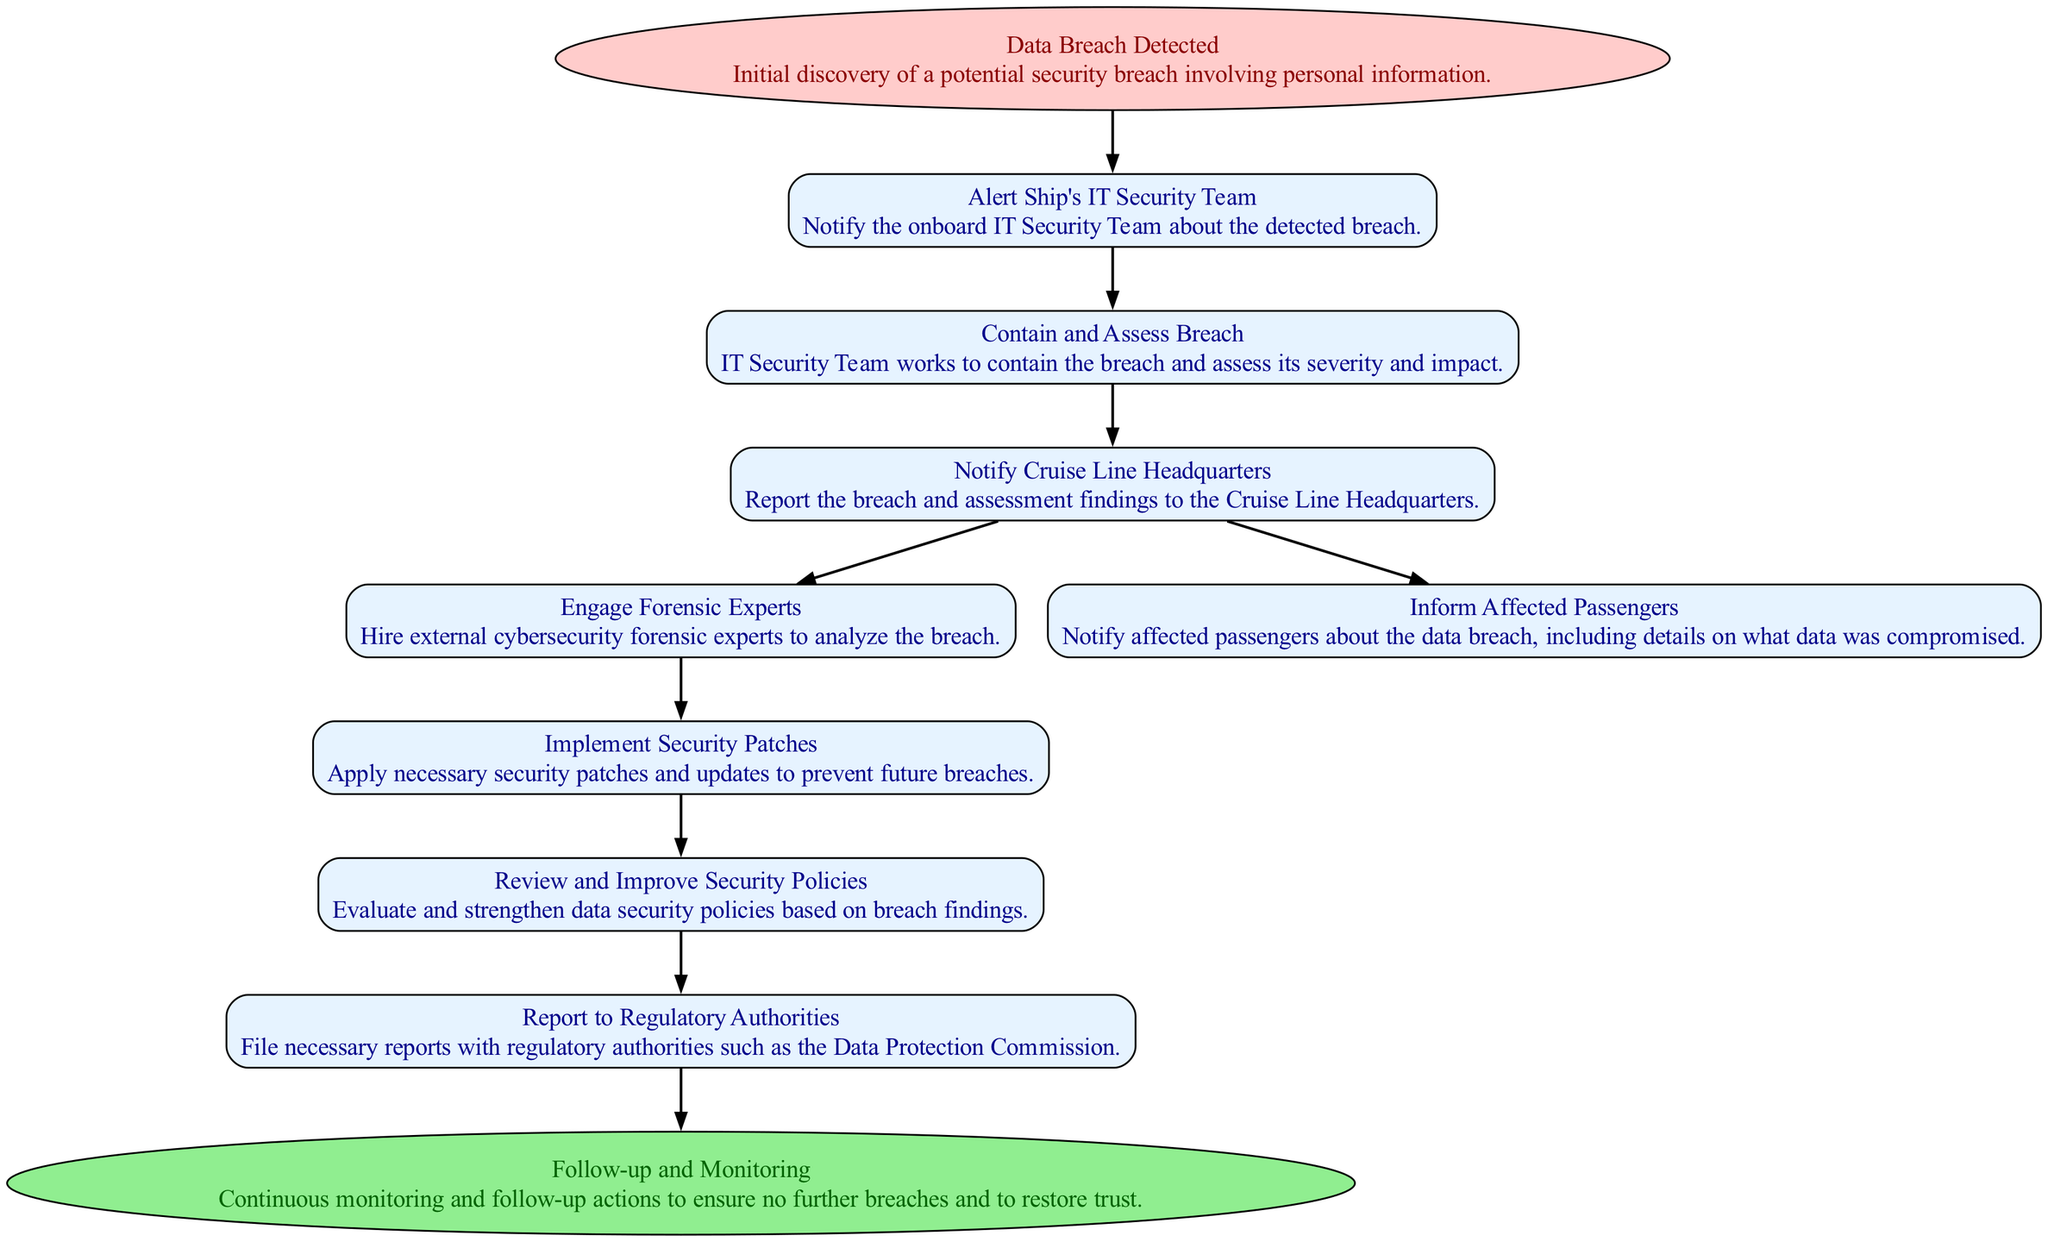What is the starting point of the data breach procedure? The starting point of the data breach procedure is the node labeled "Data Breach Detected," which indicates the initial discovery of a potential security breach involving personal information.
Answer: Data Breach Detected How many processes are there in the diagram? By counting all the nodes classified as "process" in the diagram, we find there are a total of eight process nodes, which include actions from alerting the IT security team to reporting to regulatory authorities.
Answer: Eight What action follows informing affected passengers? The action that follows informing affected passengers is "Implement Security Patches." This refers to the step taken after notifying those affected by the breach to enhance security measures.
Answer: Implement Security Patches Which node represents the final step in the procedure? The final step in the procedure is represented by the "Follow-up and Monitoring" node, indicating the continuous actions taken to ensure no further breaches and to restore trust after the incident.
Answer: Follow-up and Monitoring What is the purpose of the node "Engage Forensic Experts"? The purpose of the node "Engage Forensic Experts" is to hire external cybersecurity forensic experts to analyze the breach in detail, understanding its nature and implications for future security measures.
Answer: To analyze the breach What is the relationship between notifying the Cruise Line Headquarters and engaging forensic experts? The relationship is that upon notifying Cruise Line Headquarters about the breach and assessing its severity, the next step can include engaging forensic experts, showcasing a branching decision based on the initial report of the situation.
Answer: Two-way process What is the first action taken after a data breach is detected? The first action taken after detecting a data breach is to alert the ship's IT security team, initiating the process of addressing the breach promptly.
Answer: Alert Ship's IT Security Team Which process requires filing reports with external authorities? The process that requires filing reports with external authorities is "Report to Regulatory Authorities," ensuring compliance with legal and regulatory obligations following a data breach.
Answer: Report to Regulatory Authorities 